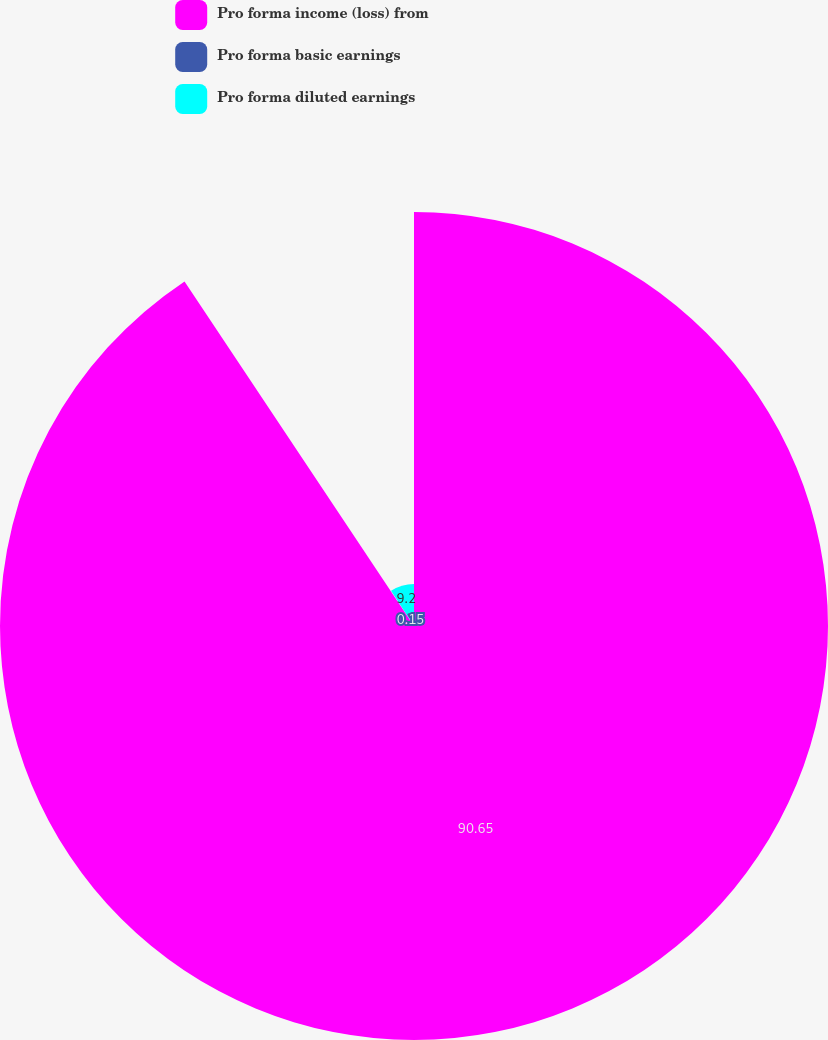Convert chart to OTSL. <chart><loc_0><loc_0><loc_500><loc_500><pie_chart><fcel>Pro forma income (loss) from<fcel>Pro forma basic earnings<fcel>Pro forma diluted earnings<nl><fcel>90.65%<fcel>0.15%<fcel>9.2%<nl></chart> 